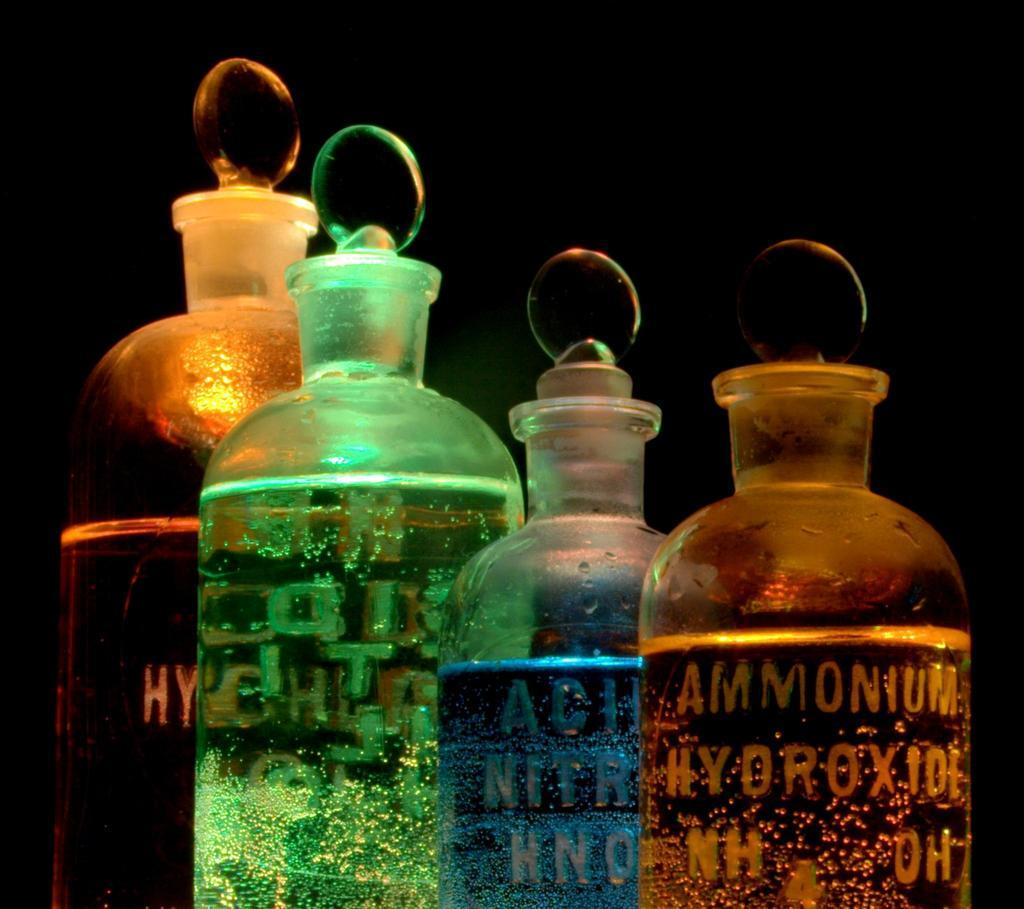<image>
Offer a succinct explanation of the picture presented. Clear stoppered bottles of chemical acis like Ammonium Hydroxide 